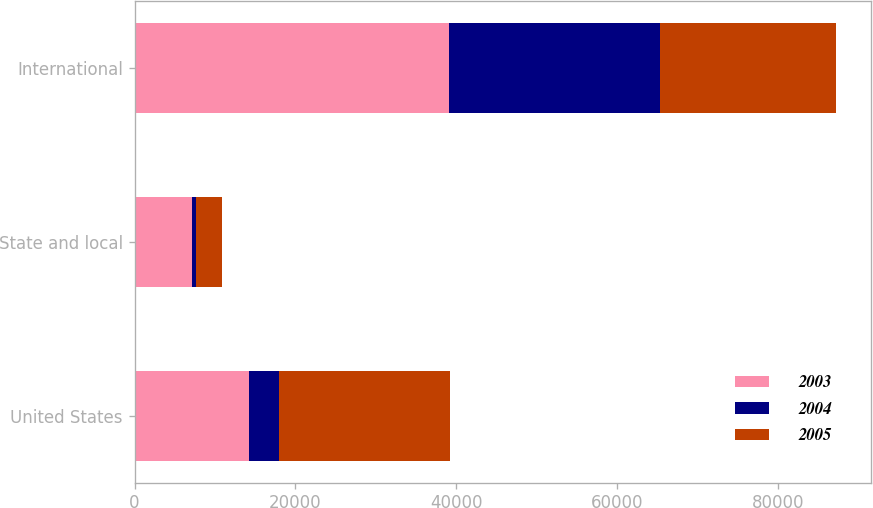Convert chart to OTSL. <chart><loc_0><loc_0><loc_500><loc_500><stacked_bar_chart><ecel><fcel>United States<fcel>State and local<fcel>International<nl><fcel>2003<fcel>14172.5<fcel>7147<fcel>39081<nl><fcel>2004<fcel>3786<fcel>497<fcel>26198<nl><fcel>2005<fcel>21198<fcel>3229<fcel>21848<nl></chart> 